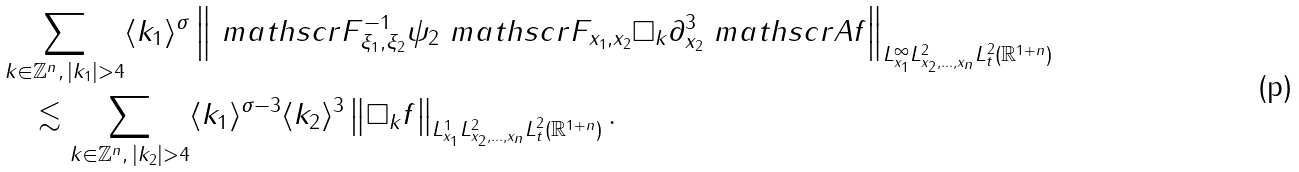Convert formula to latex. <formula><loc_0><loc_0><loc_500><loc_500>& \sum _ { k \in \mathbb { Z } ^ { n } , \, | k _ { 1 } | > 4 } \langle k _ { 1 } \rangle ^ { \sigma } \left \| \ m a t h s c r { F } ^ { - 1 } _ { \xi _ { 1 } , \xi _ { 2 } } \psi _ { 2 } \ m a t h s c r { F } _ { x _ { 1 } , x _ { 2 } } \Box _ { k } \partial ^ { 3 } _ { x _ { 2 } } \ m a t h s c r { A } f \right \| _ { L ^ { \infty } _ { x _ { 1 } } L ^ { 2 } _ { x _ { 2 } , \dots , x _ { n } } L ^ { 2 } _ { t } ( \mathbb { R } ^ { 1 + n } ) } \\ & \quad \lesssim \sum _ { k \in \mathbb { Z } ^ { n } , \, | k _ { 2 } | > 4 } \langle k _ { 1 } \rangle ^ { \sigma - 3 } \langle k _ { 2 } \rangle ^ { 3 } \left \| \Box _ { k } f \right \| _ { L ^ { 1 } _ { x _ { 1 } } L ^ { 2 } _ { x _ { 2 } , \dots , x _ { n } } L ^ { 2 } _ { t } ( \mathbb { R } ^ { 1 + n } ) } .</formula> 